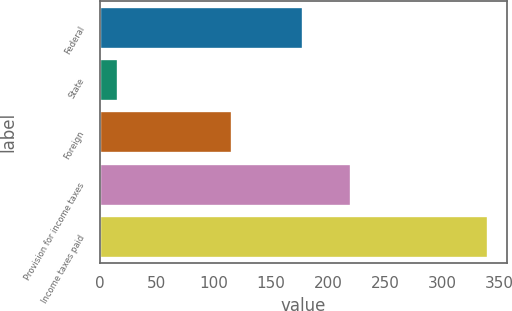<chart> <loc_0><loc_0><loc_500><loc_500><bar_chart><fcel>Federal<fcel>State<fcel>Foreign<fcel>Provision for income taxes<fcel>Income taxes paid<nl><fcel>178.2<fcel>16.5<fcel>116<fcel>220.2<fcel>340.1<nl></chart> 